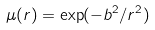Convert formula to latex. <formula><loc_0><loc_0><loc_500><loc_500>\mu ( r ) = \exp ( - b ^ { 2 } / r ^ { 2 } )</formula> 